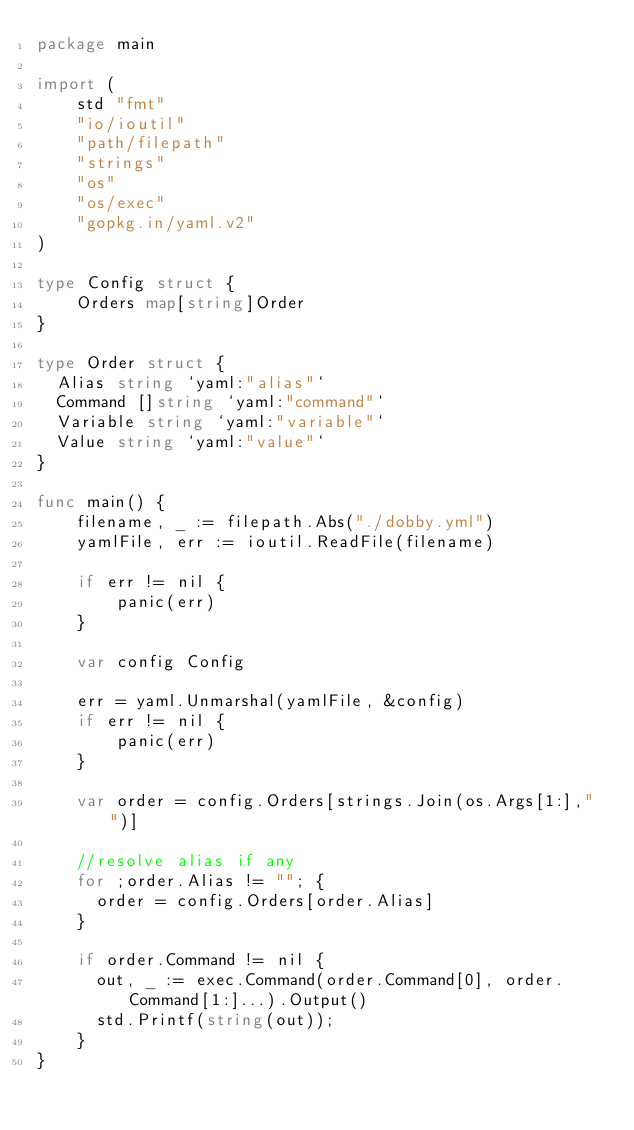Convert code to text. <code><loc_0><loc_0><loc_500><loc_500><_Go_>package main

import (
    std "fmt"
    "io/ioutil"
    "path/filepath"
    "strings"
    "os"
    "os/exec"
    "gopkg.in/yaml.v2"
)

type Config struct {
    Orders map[string]Order
}

type Order struct {
  Alias string `yaml:"alias"`
  Command []string `yaml:"command"`
  Variable string `yaml:"variable"`
  Value string `yaml:"value"`
}

func main() {
    filename, _ := filepath.Abs("./dobby.yml")
    yamlFile, err := ioutil.ReadFile(filename)

    if err != nil {
        panic(err)
    }

    var config Config

    err = yaml.Unmarshal(yamlFile, &config)
    if err != nil {
        panic(err)
    }

    var order = config.Orders[strings.Join(os.Args[1:]," ")]

    //resolve alias if any
    for ;order.Alias != ""; {
      order = config.Orders[order.Alias]
    }

    if order.Command != nil {
      out, _ := exec.Command(order.Command[0], order.Command[1:]...).Output()
      std.Printf(string(out));
    }
}
</code> 